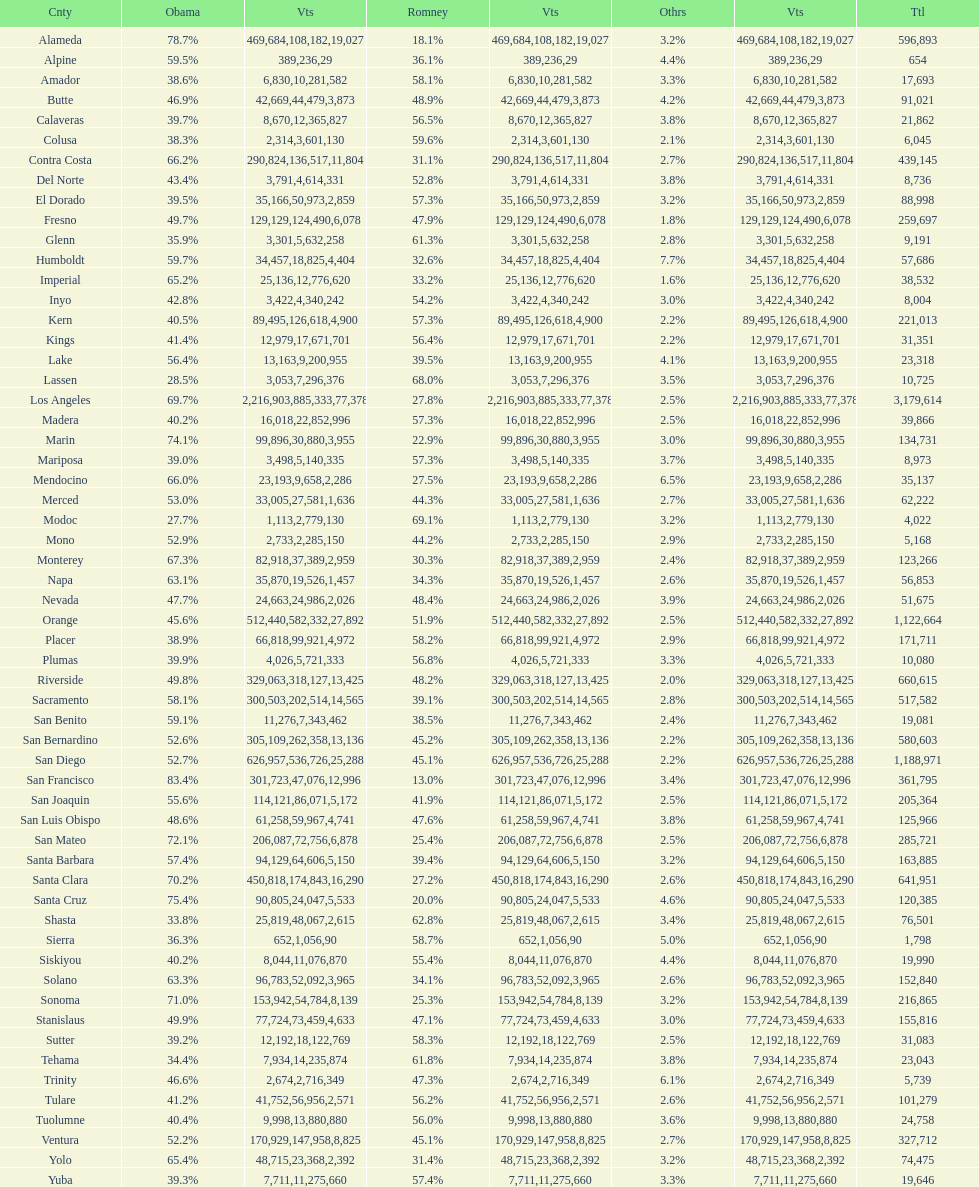How many counties had at least 75% of the votes for obama? 3. 